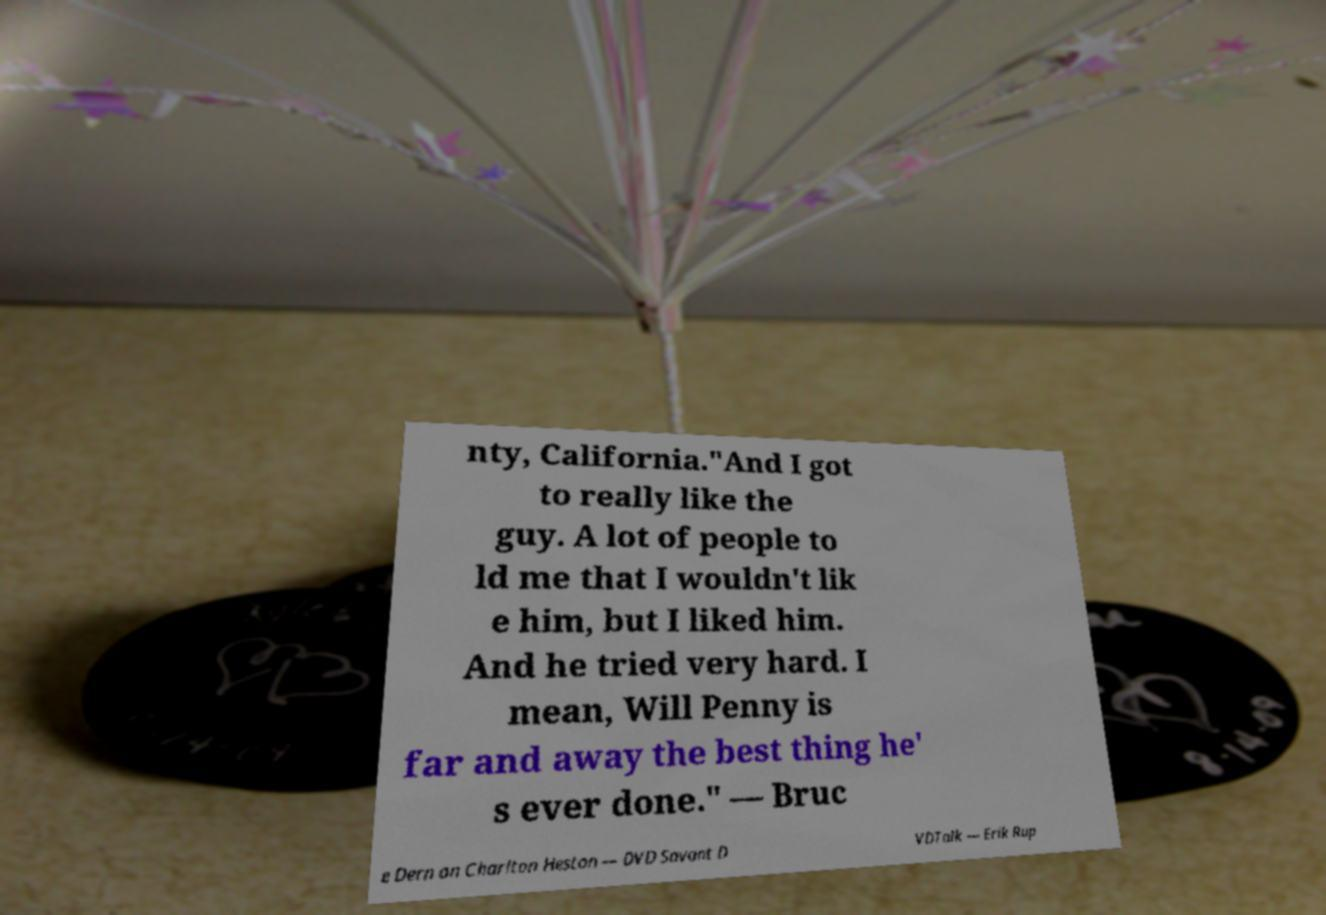Could you extract and type out the text from this image? nty, California."And I got to really like the guy. A lot of people to ld me that I wouldn't lik e him, but I liked him. And he tried very hard. I mean, Will Penny is far and away the best thing he' s ever done." — Bruc e Dern on Charlton Heston — DVD Savant D VDTalk — Erik Rup 